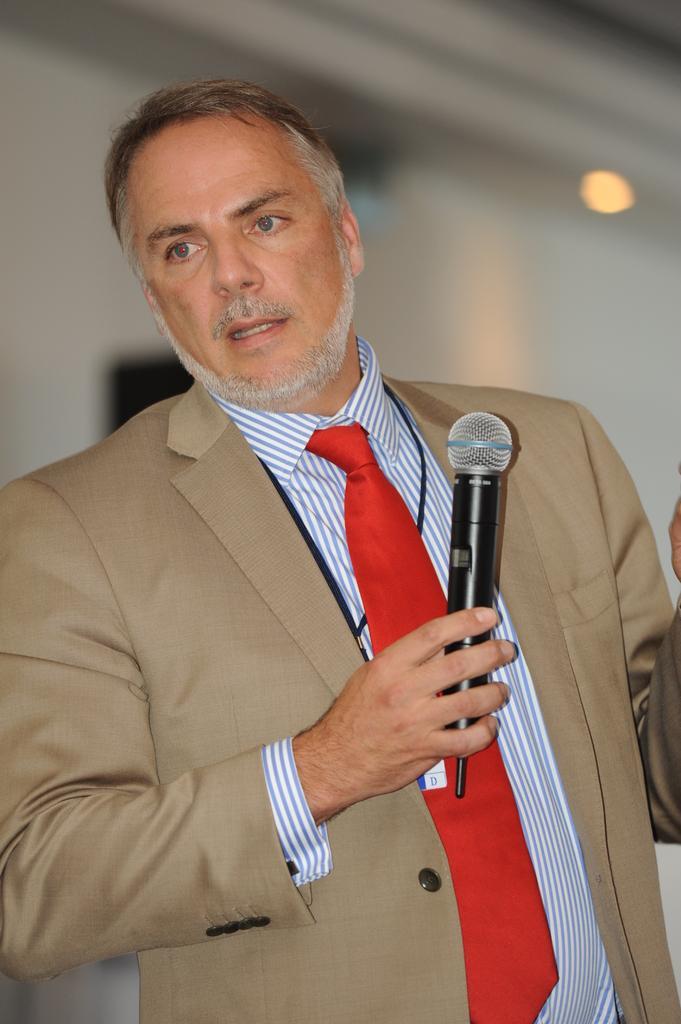In one or two sentences, can you explain what this image depicts? In this picture we can find a man with a brown suit, red tie and shirt. He is holding a microphone. In the background we can find a white wall with light. 